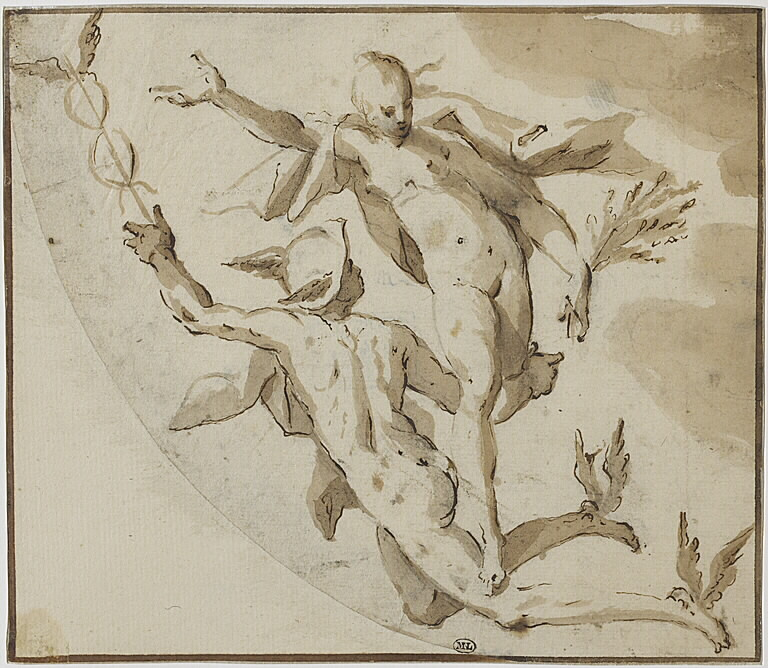Considering the historical context, how would an artist from the Baroque period approach the creation of a study like this? An artist from the Baroque period would approach the creation of a study like this with a focus on movement, energy, and theatricality, which are hallmarks of the period. They would likely begin with rough sketches to capture the overall composition and the dynamic poses of the figures. Using ink and wash, the artist would emphasize the contrast of light and shadow to create depth and drama. They would pay close attention to the anatomy and positioning of the figures, ensuring that the sense of motion is both natural and expressive. The study would serve as a preparatory work for a larger, more detailed painting or sculpture, allowing the artist to experiment with different elements of the composition before finalizing the masterpiece. 